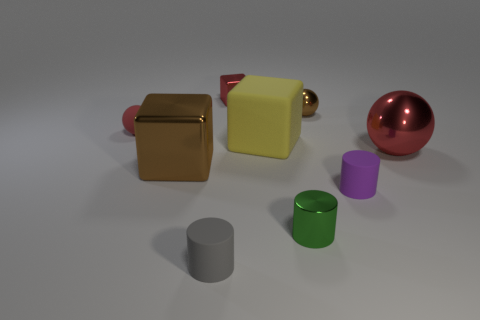Are there any other things that are the same shape as the purple object?
Offer a terse response. Yes. Is there a small yellow metallic cube?
Offer a terse response. No. Is the material of the small sphere that is right of the gray cylinder the same as the big thing that is on the left side of the tiny gray matte object?
Provide a succinct answer. Yes. What is the size of the brown metal object that is to the right of the shiny cube in front of the red ball that is on the left side of the tiny gray rubber thing?
Make the answer very short. Small. How many big brown things have the same material as the small brown thing?
Ensure brevity in your answer.  1. Is the number of yellow rubber cubes less than the number of small cylinders?
Give a very brief answer. Yes. What size is the brown metal object that is the same shape as the small red rubber object?
Make the answer very short. Small. Do the brown object that is behind the large metal sphere and the small gray object have the same material?
Offer a terse response. No. Is the green metallic object the same shape as the tiny gray thing?
Provide a short and direct response. Yes. What number of things are either objects on the right side of the brown metal block or small gray matte cylinders?
Offer a very short reply. 7. 